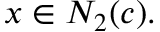<formula> <loc_0><loc_0><loc_500><loc_500>x \in N _ { 2 } ( c ) .</formula> 